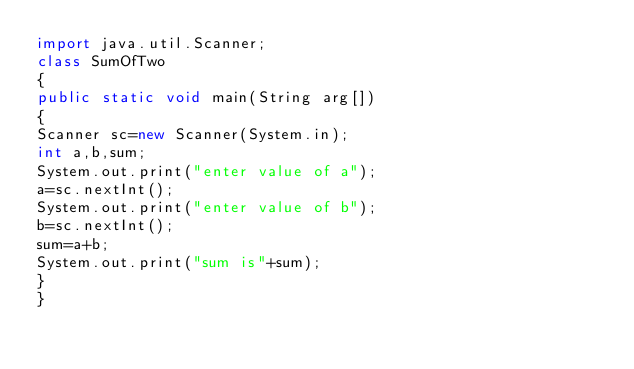Convert code to text. <code><loc_0><loc_0><loc_500><loc_500><_Java_>import java.util.Scanner;
class SumOfTwo
{
public static void main(String arg[])
{
Scanner sc=new Scanner(System.in);
int a,b,sum;
System.out.print("enter value of a");
a=sc.nextInt();
System.out.print("enter value of b");
b=sc.nextInt();
sum=a+b;
System.out.print("sum is"+sum);
}
}</code> 